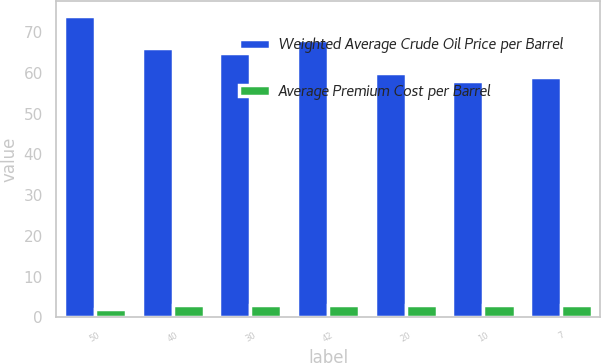Convert chart to OTSL. <chart><loc_0><loc_0><loc_500><loc_500><stacked_bar_chart><ecel><fcel>50<fcel>40<fcel>30<fcel>42<fcel>20<fcel>10<fcel>7<nl><fcel>Weighted Average Crude Oil Price per Barrel<fcel>74<fcel>66<fcel>65<fcel>68<fcel>60<fcel>58<fcel>59<nl><fcel>Average Premium Cost per Barrel<fcel>2<fcel>3<fcel>3<fcel>3<fcel>3<fcel>3<fcel>3<nl></chart> 